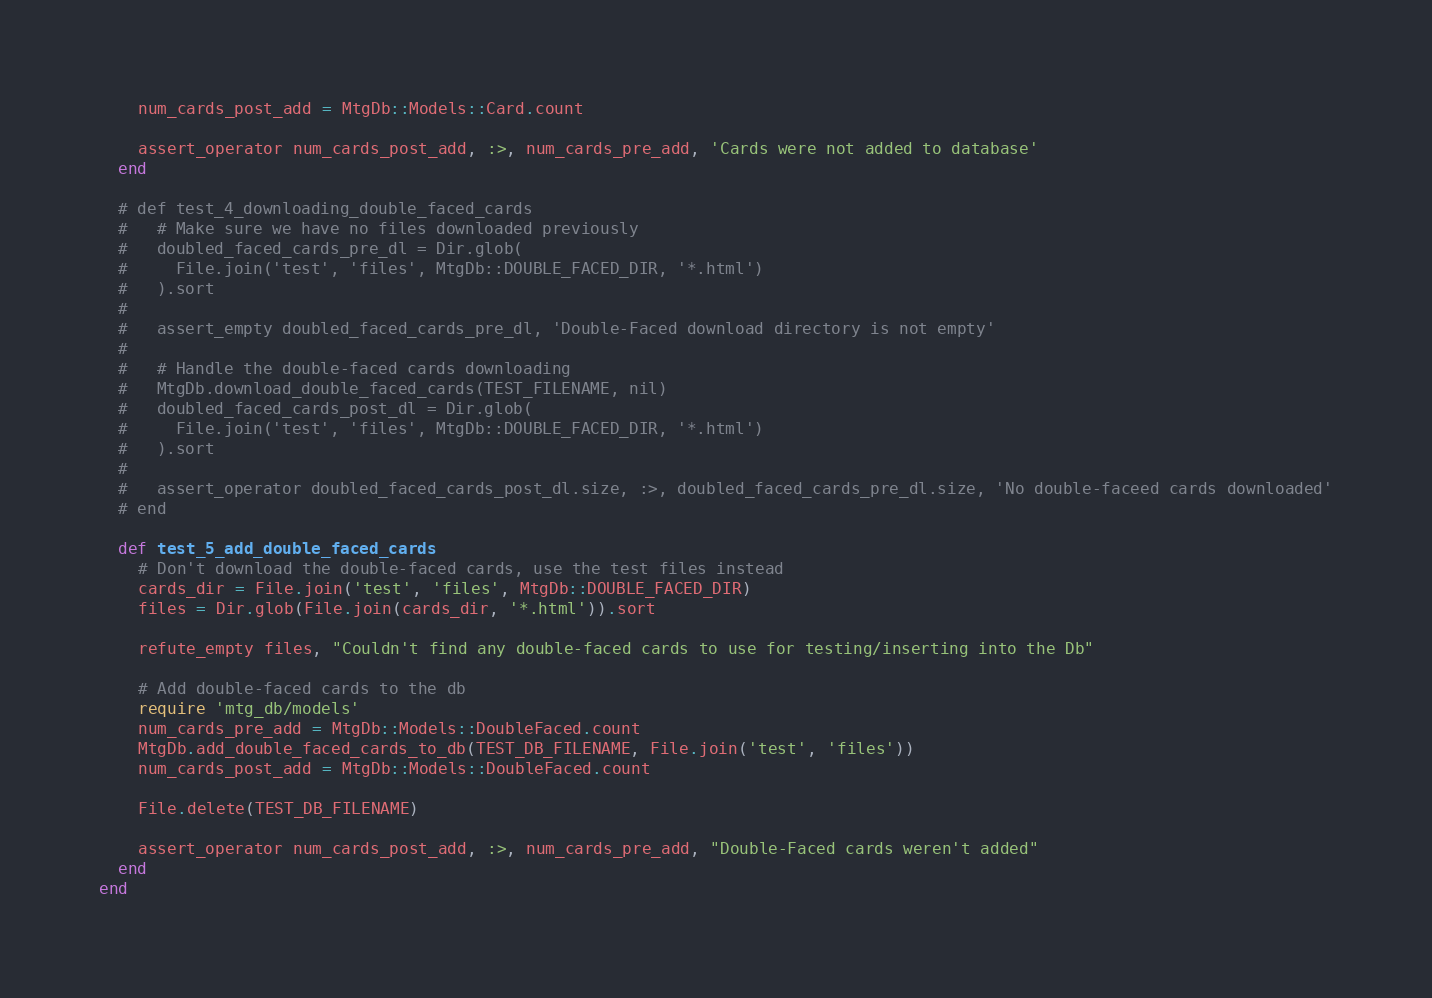Convert code to text. <code><loc_0><loc_0><loc_500><loc_500><_Ruby_>    num_cards_post_add = MtgDb::Models::Card.count

    assert_operator num_cards_post_add, :>, num_cards_pre_add, 'Cards were not added to database'
  end

  # def test_4_downloading_double_faced_cards
  #   # Make sure we have no files downloaded previously
  #   doubled_faced_cards_pre_dl = Dir.glob(
  #     File.join('test', 'files', MtgDb::DOUBLE_FACED_DIR, '*.html')
  #   ).sort
  #
  #   assert_empty doubled_faced_cards_pre_dl, 'Double-Faced download directory is not empty'
  #
  #   # Handle the double-faced cards downloading
  #   MtgDb.download_double_faced_cards(TEST_FILENAME, nil)
  #   doubled_faced_cards_post_dl = Dir.glob(
  #     File.join('test', 'files', MtgDb::DOUBLE_FACED_DIR, '*.html')
  #   ).sort
  #
  #   assert_operator doubled_faced_cards_post_dl.size, :>, doubled_faced_cards_pre_dl.size, 'No double-faceed cards downloaded'
  # end

  def test_5_add_double_faced_cards
    # Don't download the double-faced cards, use the test files instead
    cards_dir = File.join('test', 'files', MtgDb::DOUBLE_FACED_DIR)
    files = Dir.glob(File.join(cards_dir, '*.html')).sort

    refute_empty files, "Couldn't find any double-faced cards to use for testing/inserting into the Db"

    # Add double-faced cards to the db
    require 'mtg_db/models'
    num_cards_pre_add = MtgDb::Models::DoubleFaced.count
    MtgDb.add_double_faced_cards_to_db(TEST_DB_FILENAME, File.join('test', 'files'))
    num_cards_post_add = MtgDb::Models::DoubleFaced.count

    File.delete(TEST_DB_FILENAME)

    assert_operator num_cards_post_add, :>, num_cards_pre_add, "Double-Faced cards weren't added"
  end
end
</code> 